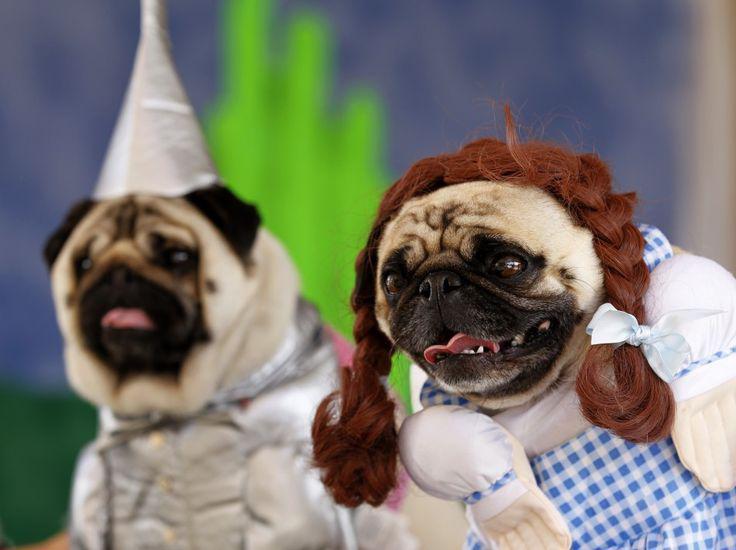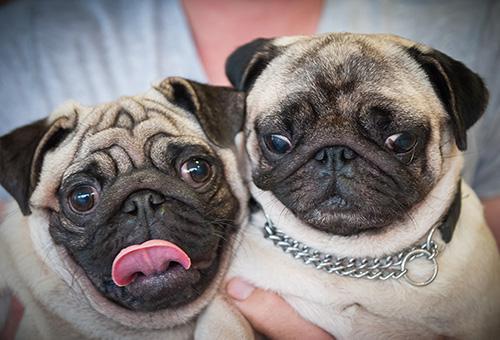The first image is the image on the left, the second image is the image on the right. For the images shown, is this caption "There are three dogs." true? Answer yes or no. No. 